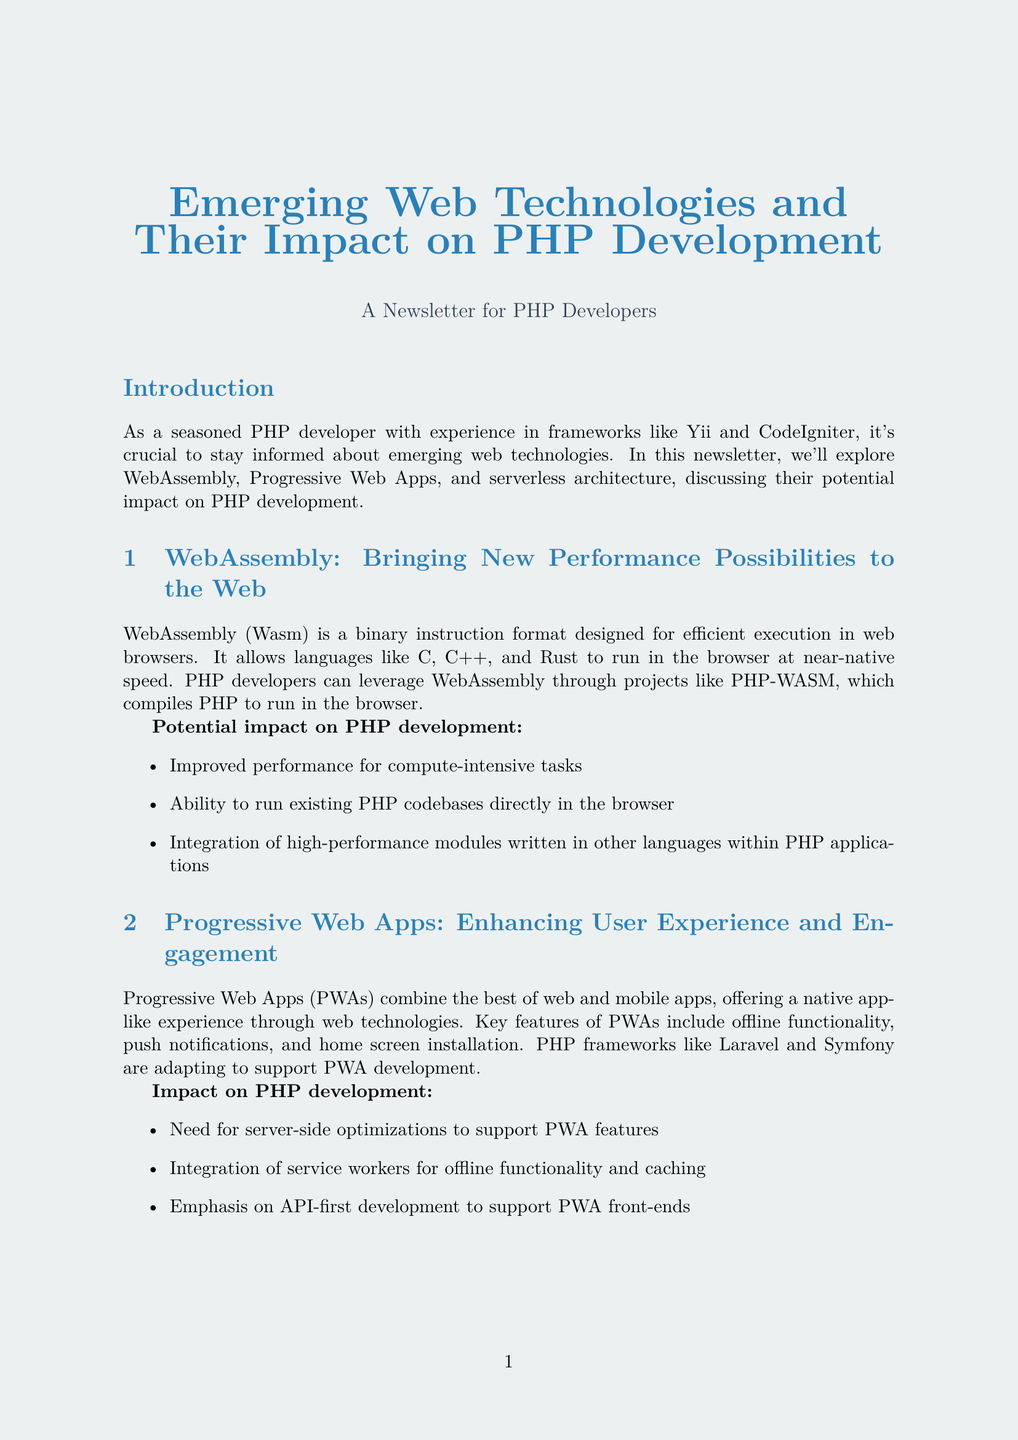What is the title of the newsletter? The title of the newsletter is presented at the beginning of the document.
Answer: Emerging Web Technologies and Their Impact on PHP Development What technology does WebAssembly allow languages like C, C++, and Rust to run at? The technology in question enables execution speed.
Answer: Near-native speed Which PHP frameworks are mentioned as adapting to support PWA development? The frameworks are explicitly stated in the document.
Answer: Laravel and Symfony What is the percentage increase in mobile conversions after modernizing the application? The increase is provided in the case study section.
Answer: 50% What project allows PHP to be used in serverless environments? The document specifies the project focused on serverless architecture.
Answer: Bref for AWS Lambda What feature of PWAs enables offline functionality? The document describes a specific technology used for this feature.
Answer: Service workers How much did the server load reduce by using WebAssembly for image processing? The case study gives this information as part of the modernization results.
Answer: 30% What is the purpose of the case study? The case study showcases practical application, as stated in its description.
Answer: Modernizing a Legacy PHP Application 